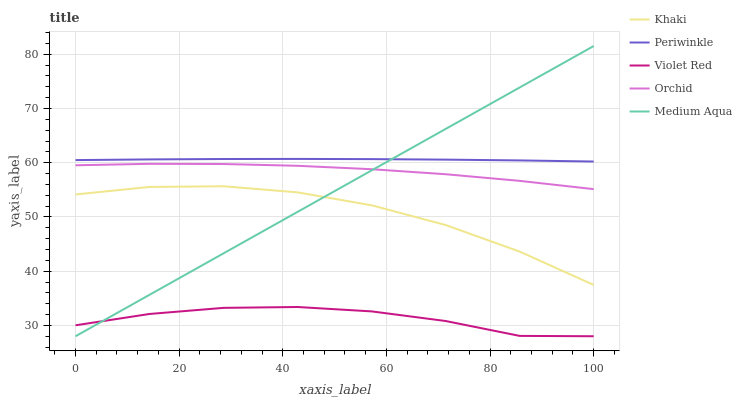Does Violet Red have the minimum area under the curve?
Answer yes or no. Yes. Does Periwinkle have the maximum area under the curve?
Answer yes or no. Yes. Does Khaki have the minimum area under the curve?
Answer yes or no. No. Does Khaki have the maximum area under the curve?
Answer yes or no. No. Is Medium Aqua the smoothest?
Answer yes or no. Yes. Is Khaki the roughest?
Answer yes or no. Yes. Is Violet Red the smoothest?
Answer yes or no. No. Is Violet Red the roughest?
Answer yes or no. No. Does Medium Aqua have the lowest value?
Answer yes or no. Yes. Does Khaki have the lowest value?
Answer yes or no. No. Does Medium Aqua have the highest value?
Answer yes or no. Yes. Does Khaki have the highest value?
Answer yes or no. No. Is Violet Red less than Orchid?
Answer yes or no. Yes. Is Periwinkle greater than Khaki?
Answer yes or no. Yes. Does Medium Aqua intersect Violet Red?
Answer yes or no. Yes. Is Medium Aqua less than Violet Red?
Answer yes or no. No. Is Medium Aqua greater than Violet Red?
Answer yes or no. No. Does Violet Red intersect Orchid?
Answer yes or no. No. 